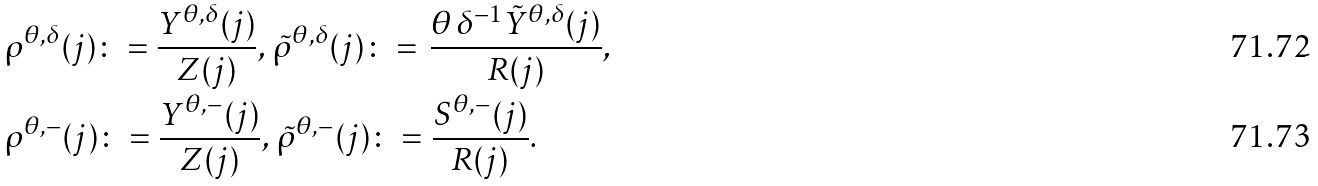<formula> <loc_0><loc_0><loc_500><loc_500>& \rho ^ { \theta , \delta } ( j ) \colon = \frac { Y ^ { \theta , \delta } ( j ) } { Z ( j ) } , \, \tilde { \rho } ^ { \theta , \delta } ( j ) \colon = \, \frac { \theta \, \delta ^ { - 1 } \tilde { Y } ^ { \theta , \delta } ( j ) } { R ( j ) } , \\ & \rho ^ { \theta , - } ( j ) \colon = \frac { Y ^ { \theta , - } ( j ) } { Z ( j ) } , \, \tilde { \rho } ^ { \theta , - } ( j ) \colon = \frac { S ^ { \theta , - } ( j ) } { R ( j ) } .</formula> 